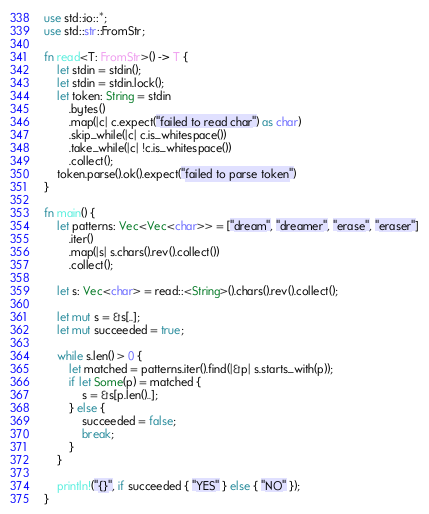<code> <loc_0><loc_0><loc_500><loc_500><_Rust_>use std::io::*;
use std::str::FromStr;

fn read<T: FromStr>() -> T {
    let stdin = stdin();
    let stdin = stdin.lock();
    let token: String = stdin
        .bytes()
        .map(|c| c.expect("failed to read char") as char) 
        .skip_while(|c| c.is_whitespace())
        .take_while(|c| !c.is_whitespace())
        .collect();
    token.parse().ok().expect("failed to parse token")
}

fn main() {
    let patterns: Vec<Vec<char>> = ["dream", "dreamer", "erase", "eraser"]
        .iter()
        .map(|s| s.chars().rev().collect())
        .collect();

    let s: Vec<char> = read::<String>().chars().rev().collect();

    let mut s = &s[..];
    let mut succeeded = true;

    while s.len() > 0 {
        let matched = patterns.iter().find(|&p| s.starts_with(p));
        if let Some(p) = matched {
            s = &s[p.len()..];
        } else {
            succeeded = false;
            break;
        }
    }

    println!("{}", if succeeded { "YES" } else { "NO" });
}
</code> 